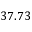<formula> <loc_0><loc_0><loc_500><loc_500>3 7 . 7 3</formula> 